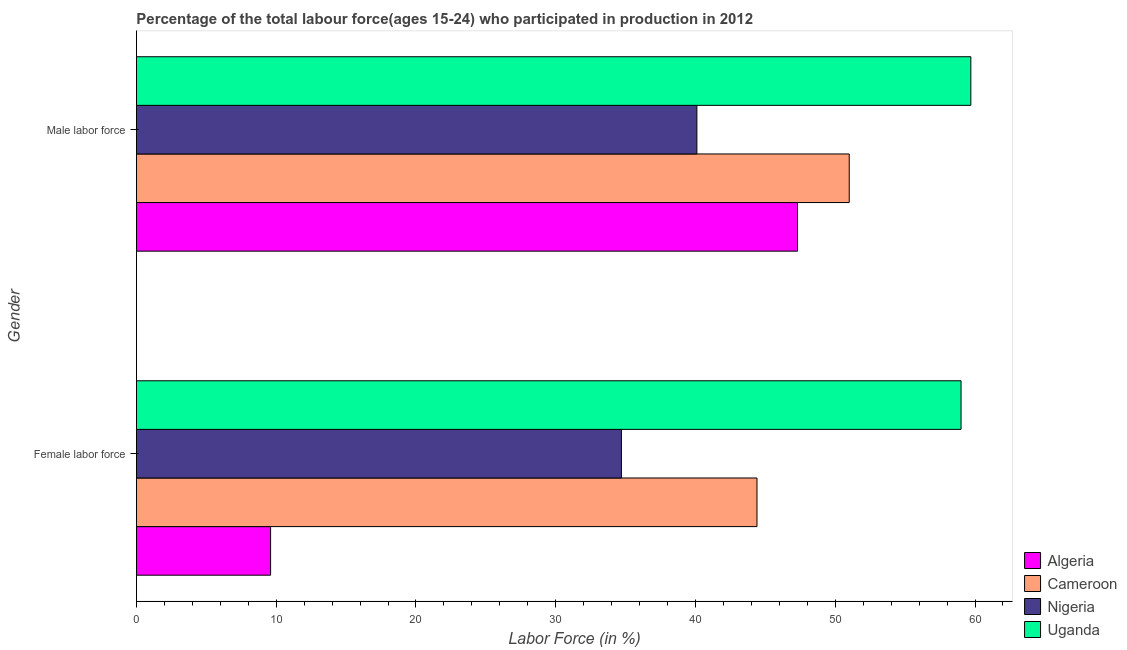How many different coloured bars are there?
Keep it short and to the point. 4. How many groups of bars are there?
Make the answer very short. 2. How many bars are there on the 1st tick from the top?
Your response must be concise. 4. What is the label of the 2nd group of bars from the top?
Provide a short and direct response. Female labor force. What is the percentage of female labor force in Cameroon?
Give a very brief answer. 44.4. Across all countries, what is the minimum percentage of female labor force?
Make the answer very short. 9.6. In which country was the percentage of male labour force maximum?
Keep it short and to the point. Uganda. In which country was the percentage of female labor force minimum?
Provide a succinct answer. Algeria. What is the total percentage of female labor force in the graph?
Keep it short and to the point. 147.7. What is the difference between the percentage of male labour force in Algeria and that in Cameroon?
Provide a short and direct response. -3.7. What is the difference between the percentage of male labour force in Cameroon and the percentage of female labor force in Uganda?
Offer a terse response. -8. What is the average percentage of male labour force per country?
Your answer should be compact. 49.52. What is the difference between the percentage of female labor force and percentage of male labour force in Algeria?
Keep it short and to the point. -37.7. In how many countries, is the percentage of female labor force greater than 6 %?
Your response must be concise. 4. What is the ratio of the percentage of male labour force in Uganda to that in Algeria?
Provide a short and direct response. 1.26. Is the percentage of female labor force in Nigeria less than that in Cameroon?
Make the answer very short. Yes. What does the 4th bar from the top in Male labor force represents?
Your answer should be compact. Algeria. What does the 4th bar from the bottom in Female labor force represents?
Your answer should be compact. Uganda. How many countries are there in the graph?
Your answer should be compact. 4. What is the difference between two consecutive major ticks on the X-axis?
Your answer should be very brief. 10. Where does the legend appear in the graph?
Provide a short and direct response. Bottom right. How many legend labels are there?
Provide a short and direct response. 4. What is the title of the graph?
Ensure brevity in your answer.  Percentage of the total labour force(ages 15-24) who participated in production in 2012. What is the Labor Force (in %) of Algeria in Female labor force?
Offer a terse response. 9.6. What is the Labor Force (in %) of Cameroon in Female labor force?
Make the answer very short. 44.4. What is the Labor Force (in %) in Nigeria in Female labor force?
Your answer should be very brief. 34.7. What is the Labor Force (in %) of Algeria in Male labor force?
Make the answer very short. 47.3. What is the Labor Force (in %) of Cameroon in Male labor force?
Keep it short and to the point. 51. What is the Labor Force (in %) in Nigeria in Male labor force?
Keep it short and to the point. 40.1. What is the Labor Force (in %) of Uganda in Male labor force?
Give a very brief answer. 59.7. Across all Gender, what is the maximum Labor Force (in %) of Algeria?
Ensure brevity in your answer.  47.3. Across all Gender, what is the maximum Labor Force (in %) in Cameroon?
Your response must be concise. 51. Across all Gender, what is the maximum Labor Force (in %) of Nigeria?
Give a very brief answer. 40.1. Across all Gender, what is the maximum Labor Force (in %) in Uganda?
Make the answer very short. 59.7. Across all Gender, what is the minimum Labor Force (in %) in Algeria?
Give a very brief answer. 9.6. Across all Gender, what is the minimum Labor Force (in %) of Cameroon?
Make the answer very short. 44.4. Across all Gender, what is the minimum Labor Force (in %) of Nigeria?
Offer a very short reply. 34.7. Across all Gender, what is the minimum Labor Force (in %) of Uganda?
Offer a very short reply. 59. What is the total Labor Force (in %) in Algeria in the graph?
Your answer should be very brief. 56.9. What is the total Labor Force (in %) of Cameroon in the graph?
Give a very brief answer. 95.4. What is the total Labor Force (in %) in Nigeria in the graph?
Give a very brief answer. 74.8. What is the total Labor Force (in %) of Uganda in the graph?
Provide a short and direct response. 118.7. What is the difference between the Labor Force (in %) of Algeria in Female labor force and that in Male labor force?
Provide a succinct answer. -37.7. What is the difference between the Labor Force (in %) in Cameroon in Female labor force and that in Male labor force?
Your response must be concise. -6.6. What is the difference between the Labor Force (in %) in Nigeria in Female labor force and that in Male labor force?
Provide a succinct answer. -5.4. What is the difference between the Labor Force (in %) in Uganda in Female labor force and that in Male labor force?
Ensure brevity in your answer.  -0.7. What is the difference between the Labor Force (in %) in Algeria in Female labor force and the Labor Force (in %) in Cameroon in Male labor force?
Keep it short and to the point. -41.4. What is the difference between the Labor Force (in %) of Algeria in Female labor force and the Labor Force (in %) of Nigeria in Male labor force?
Make the answer very short. -30.5. What is the difference between the Labor Force (in %) of Algeria in Female labor force and the Labor Force (in %) of Uganda in Male labor force?
Your answer should be very brief. -50.1. What is the difference between the Labor Force (in %) of Cameroon in Female labor force and the Labor Force (in %) of Nigeria in Male labor force?
Your response must be concise. 4.3. What is the difference between the Labor Force (in %) of Cameroon in Female labor force and the Labor Force (in %) of Uganda in Male labor force?
Keep it short and to the point. -15.3. What is the average Labor Force (in %) in Algeria per Gender?
Your answer should be very brief. 28.45. What is the average Labor Force (in %) of Cameroon per Gender?
Offer a terse response. 47.7. What is the average Labor Force (in %) in Nigeria per Gender?
Offer a terse response. 37.4. What is the average Labor Force (in %) of Uganda per Gender?
Make the answer very short. 59.35. What is the difference between the Labor Force (in %) in Algeria and Labor Force (in %) in Cameroon in Female labor force?
Your answer should be compact. -34.8. What is the difference between the Labor Force (in %) of Algeria and Labor Force (in %) of Nigeria in Female labor force?
Provide a succinct answer. -25.1. What is the difference between the Labor Force (in %) of Algeria and Labor Force (in %) of Uganda in Female labor force?
Make the answer very short. -49.4. What is the difference between the Labor Force (in %) in Cameroon and Labor Force (in %) in Nigeria in Female labor force?
Provide a succinct answer. 9.7. What is the difference between the Labor Force (in %) in Cameroon and Labor Force (in %) in Uganda in Female labor force?
Give a very brief answer. -14.6. What is the difference between the Labor Force (in %) of Nigeria and Labor Force (in %) of Uganda in Female labor force?
Offer a very short reply. -24.3. What is the difference between the Labor Force (in %) in Algeria and Labor Force (in %) in Nigeria in Male labor force?
Give a very brief answer. 7.2. What is the difference between the Labor Force (in %) in Algeria and Labor Force (in %) in Uganda in Male labor force?
Offer a very short reply. -12.4. What is the difference between the Labor Force (in %) in Cameroon and Labor Force (in %) in Nigeria in Male labor force?
Keep it short and to the point. 10.9. What is the difference between the Labor Force (in %) of Nigeria and Labor Force (in %) of Uganda in Male labor force?
Provide a succinct answer. -19.6. What is the ratio of the Labor Force (in %) of Algeria in Female labor force to that in Male labor force?
Make the answer very short. 0.2. What is the ratio of the Labor Force (in %) of Cameroon in Female labor force to that in Male labor force?
Make the answer very short. 0.87. What is the ratio of the Labor Force (in %) of Nigeria in Female labor force to that in Male labor force?
Provide a succinct answer. 0.87. What is the ratio of the Labor Force (in %) in Uganda in Female labor force to that in Male labor force?
Keep it short and to the point. 0.99. What is the difference between the highest and the second highest Labor Force (in %) of Algeria?
Your response must be concise. 37.7. What is the difference between the highest and the second highest Labor Force (in %) in Cameroon?
Offer a terse response. 6.6. What is the difference between the highest and the second highest Labor Force (in %) in Uganda?
Your answer should be compact. 0.7. What is the difference between the highest and the lowest Labor Force (in %) of Algeria?
Your answer should be very brief. 37.7. What is the difference between the highest and the lowest Labor Force (in %) of Cameroon?
Give a very brief answer. 6.6. What is the difference between the highest and the lowest Labor Force (in %) in Nigeria?
Your answer should be compact. 5.4. 